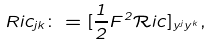<formula> <loc_0><loc_0><loc_500><loc_500>{ R i c _ { j k } \colon = [ \frac { 1 } { 2 } F ^ { 2 } \mathcal { R } i c ] _ { y ^ { j } y ^ { k } } } ,</formula> 